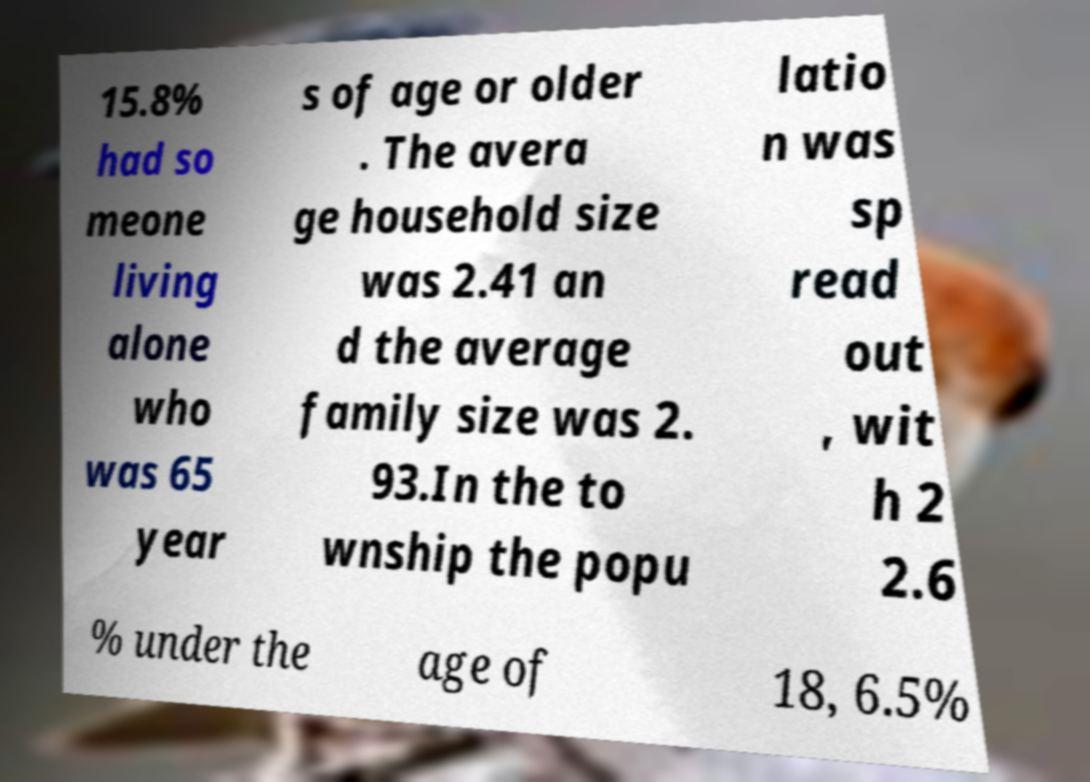For documentation purposes, I need the text within this image transcribed. Could you provide that? 15.8% had so meone living alone who was 65 year s of age or older . The avera ge household size was 2.41 an d the average family size was 2. 93.In the to wnship the popu latio n was sp read out , wit h 2 2.6 % under the age of 18, 6.5% 